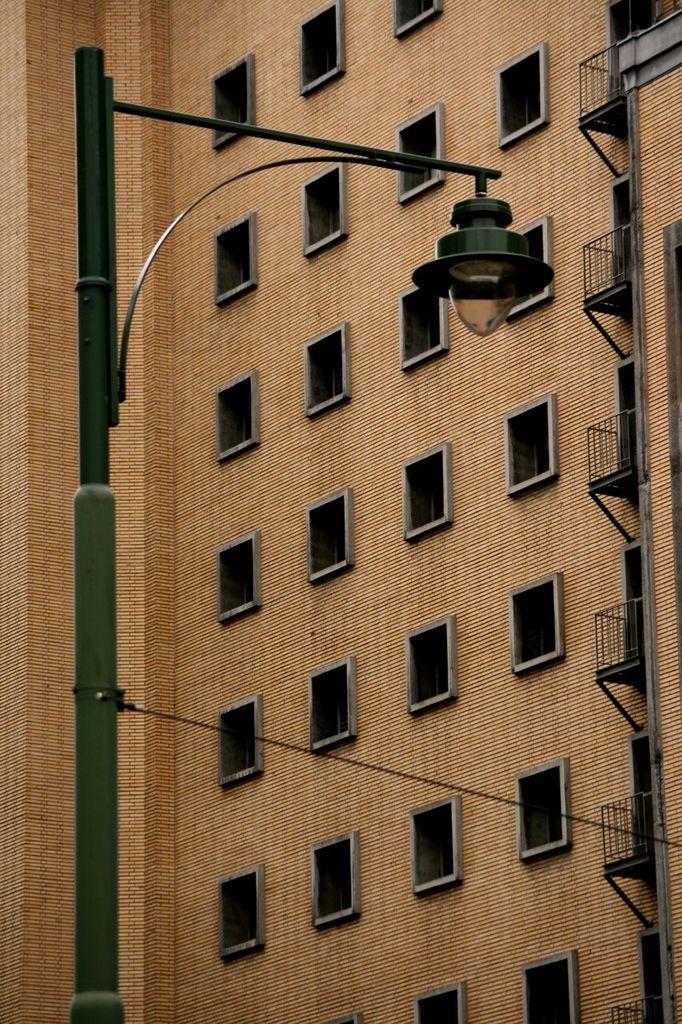How would you summarize this image in a sentence or two? There is a light pole. In the back there is a building with windows and balcony. 